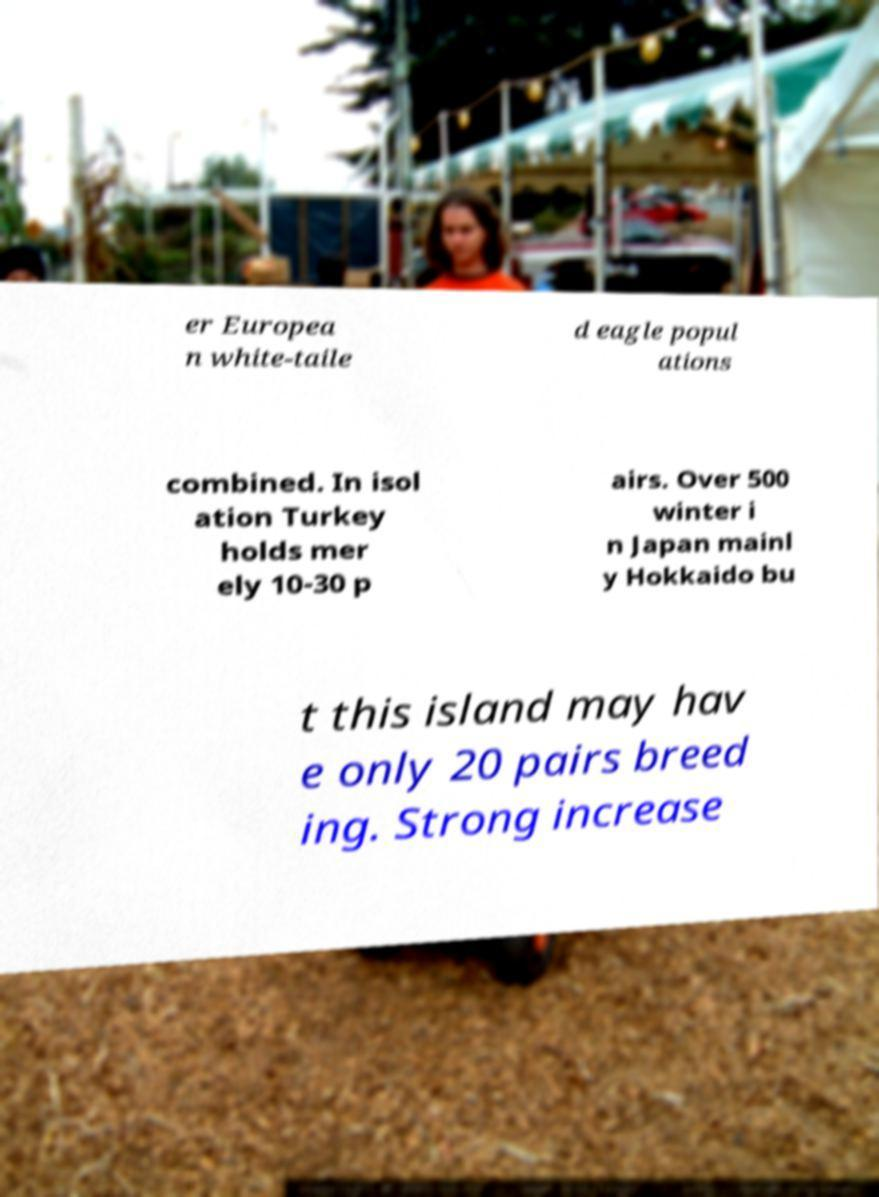Can you read and provide the text displayed in the image?This photo seems to have some interesting text. Can you extract and type it out for me? er Europea n white-taile d eagle popul ations combined. In isol ation Turkey holds mer ely 10-30 p airs. Over 500 winter i n Japan mainl y Hokkaido bu t this island may hav e only 20 pairs breed ing. Strong increase 